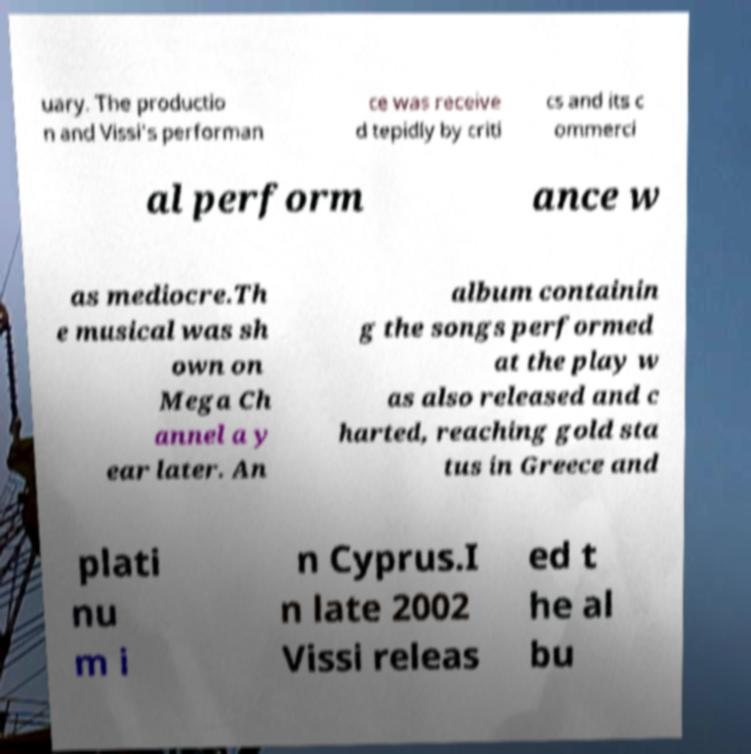For documentation purposes, I need the text within this image transcribed. Could you provide that? uary. The productio n and Vissi's performan ce was receive d tepidly by criti cs and its c ommerci al perform ance w as mediocre.Th e musical was sh own on Mega Ch annel a y ear later. An album containin g the songs performed at the play w as also released and c harted, reaching gold sta tus in Greece and plati nu m i n Cyprus.I n late 2002 Vissi releas ed t he al bu 